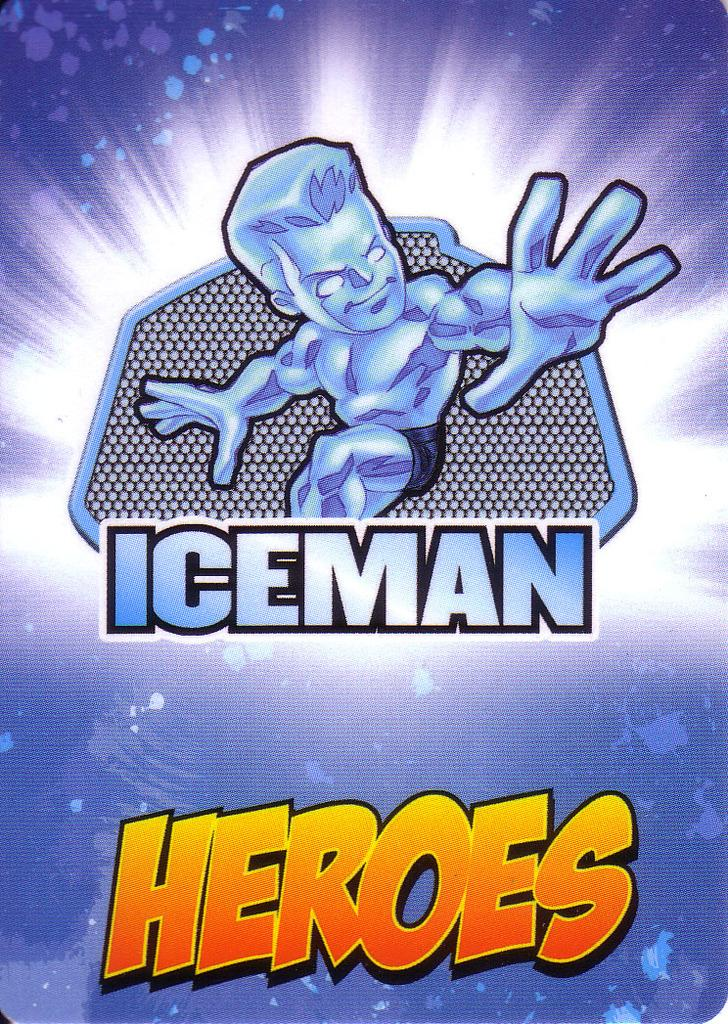<image>
Offer a succinct explanation of the picture presented. A poster features a cartoon goalie above the words Iceman Heroes. 